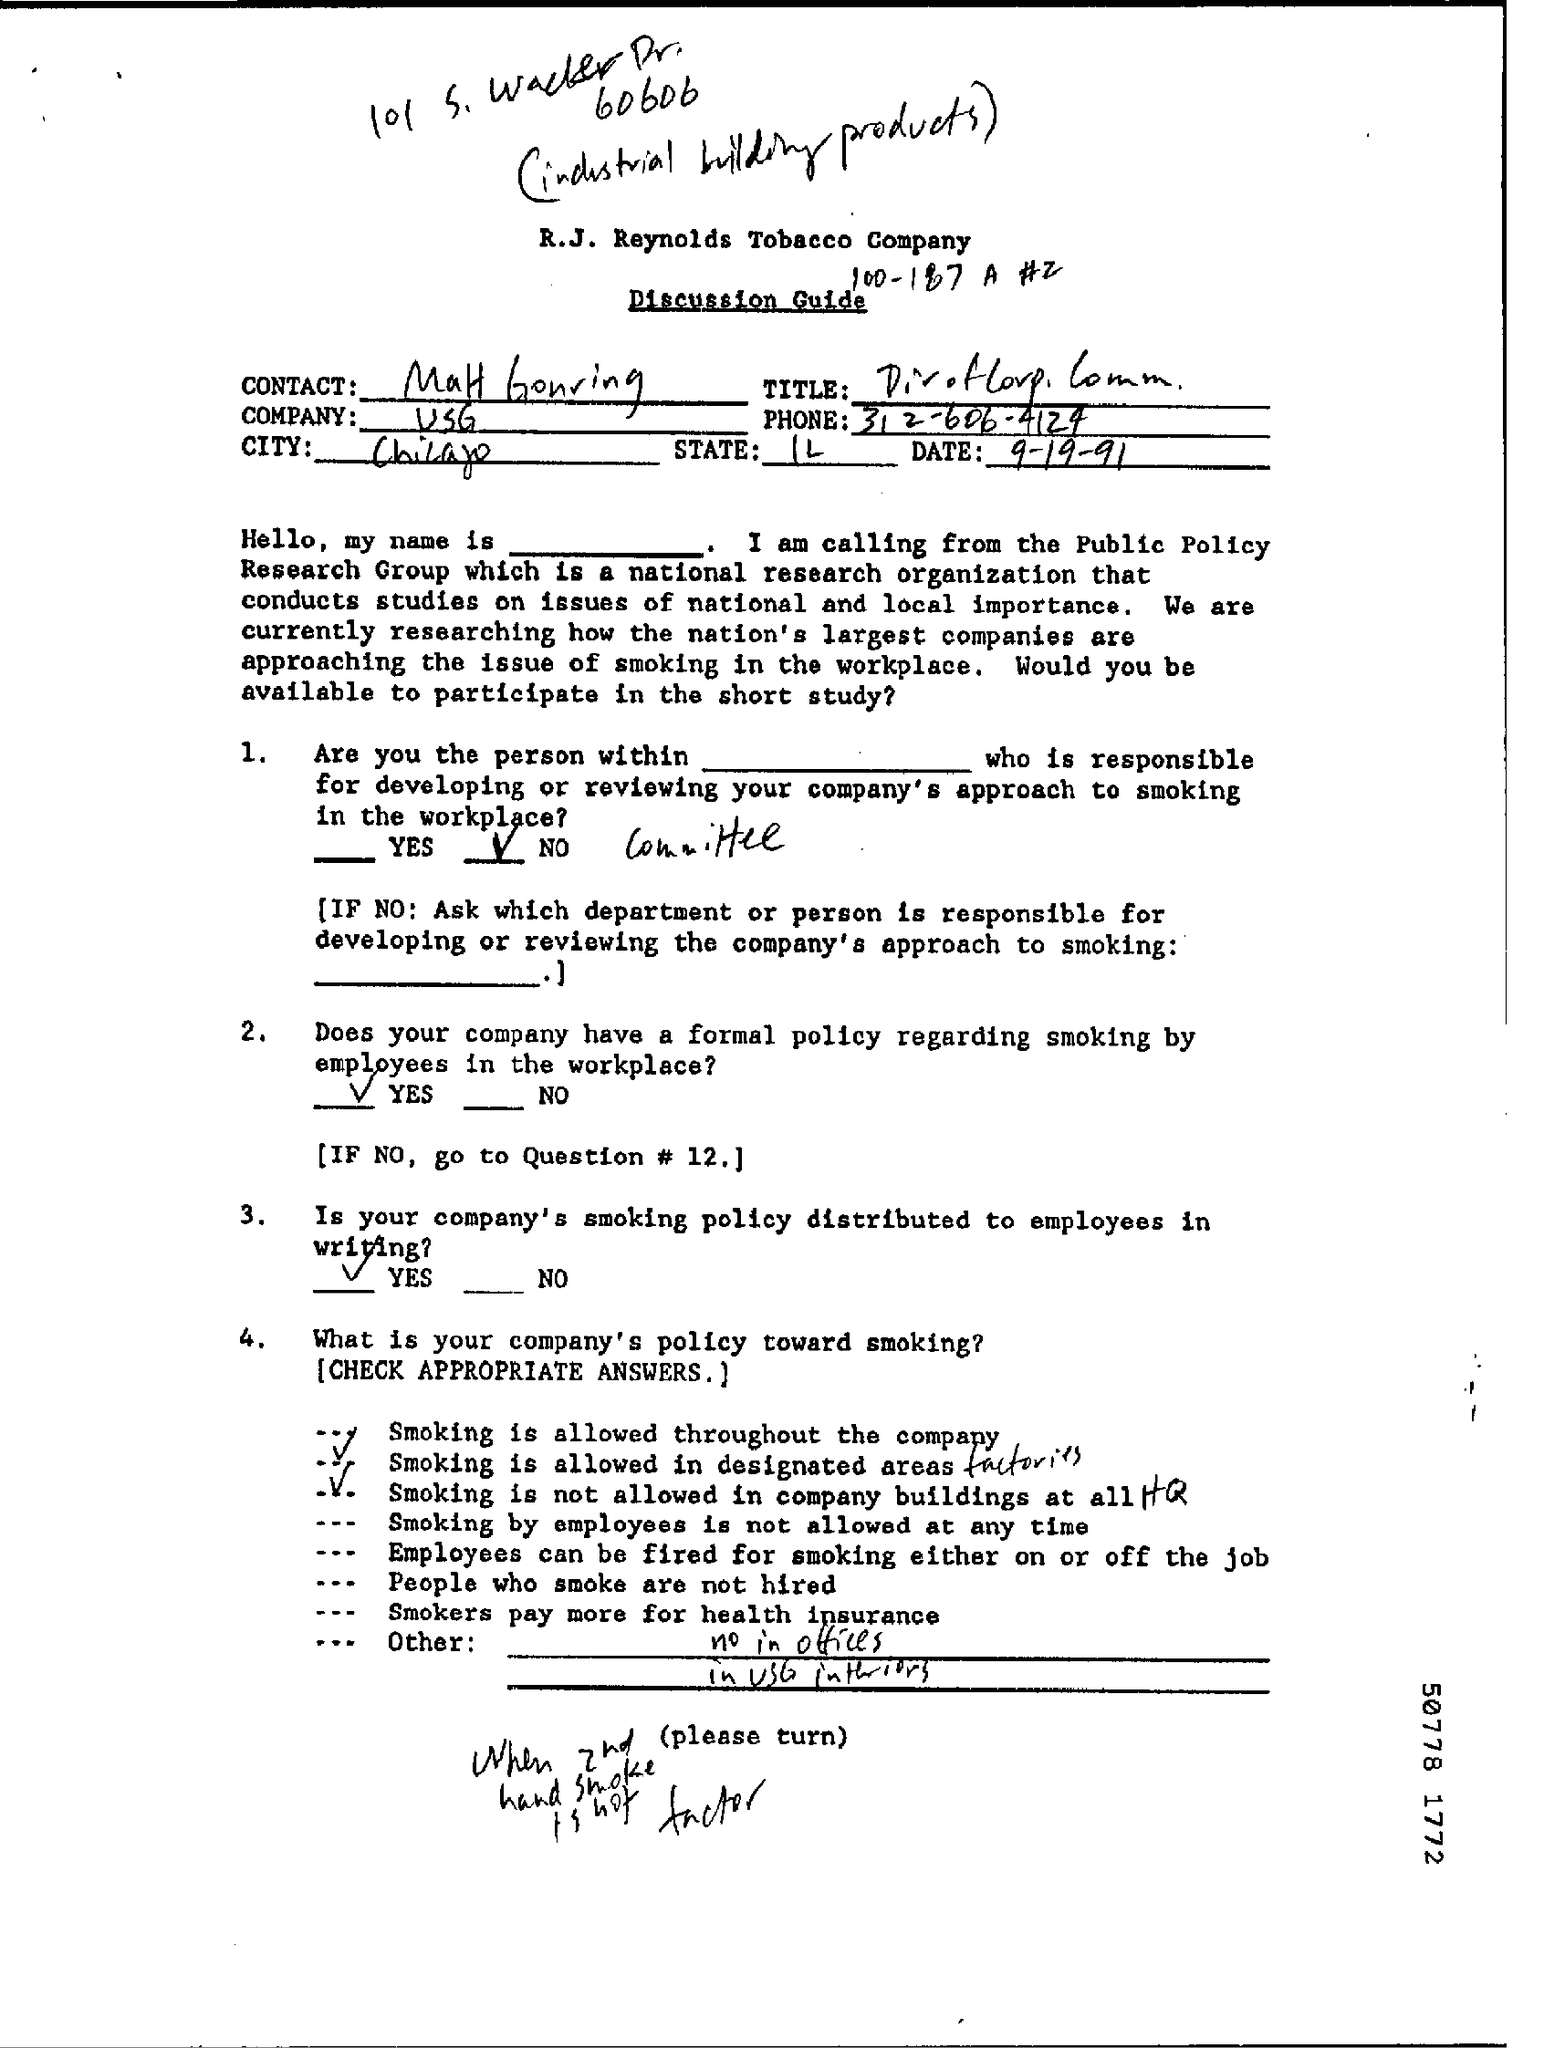List a handful of essential elements in this visual. The phone number is 312-606-4124. The date is September 19, 1991. The city of Chicago is the focus of this discourse, a metropolis known for its iconic architecture, diverse cultural landscape, and rich history. The title of the document is 'Discussion Guide'. The state of Illinois is a political entity that is recognized by the federal government. 